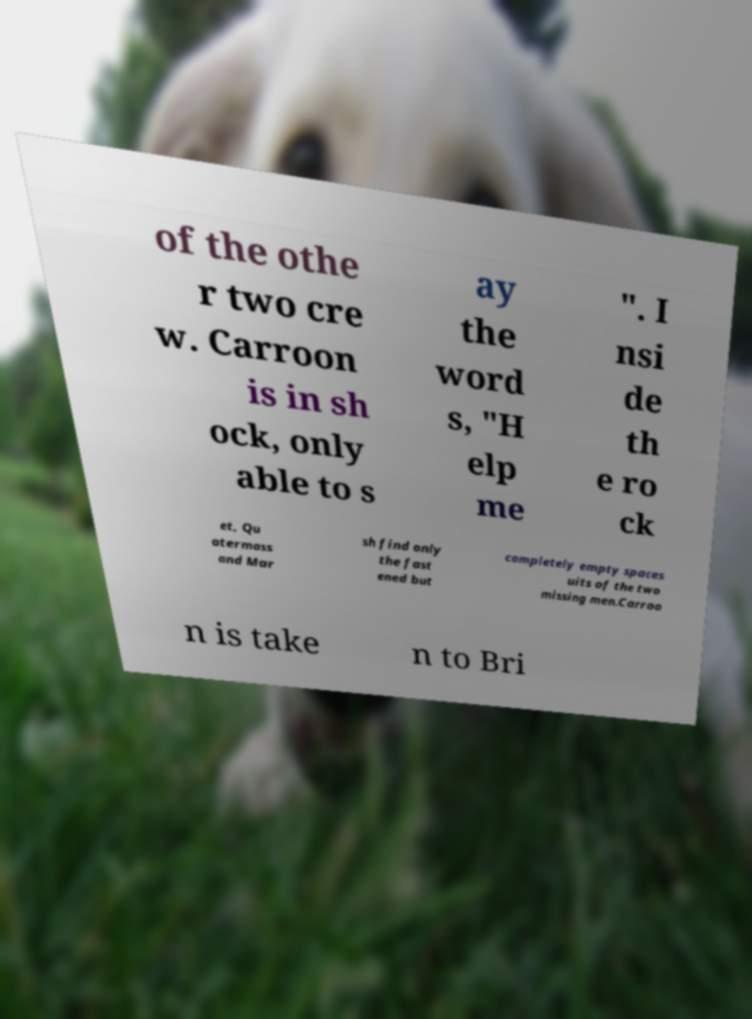There's text embedded in this image that I need extracted. Can you transcribe it verbatim? of the othe r two cre w. Carroon is in sh ock, only able to s ay the word s, "H elp me ". I nsi de th e ro ck et, Qu atermass and Mar sh find only the fast ened but completely empty spaces uits of the two missing men.Carroo n is take n to Bri 